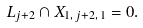Convert formula to latex. <formula><loc_0><loc_0><loc_500><loc_500>L _ { j + 2 } \cap X _ { 1 , \, j + 2 , \, 1 } = 0 .</formula> 